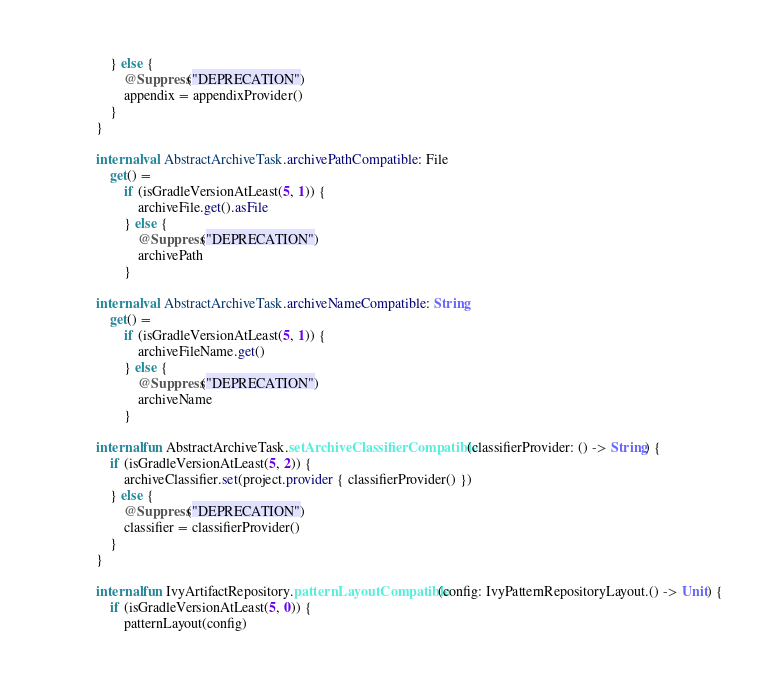<code> <loc_0><loc_0><loc_500><loc_500><_Kotlin_>    } else {
        @Suppress("DEPRECATION")
        appendix = appendixProvider()
    }
}

internal val AbstractArchiveTask.archivePathCompatible: File
    get() =
        if (isGradleVersionAtLeast(5, 1)) {
            archiveFile.get().asFile
        } else {
            @Suppress("DEPRECATION")
            archivePath
        }

internal val AbstractArchiveTask.archiveNameCompatible: String
    get() =
        if (isGradleVersionAtLeast(5, 1)) {
            archiveFileName.get()
        } else {
            @Suppress("DEPRECATION")
            archiveName
        }

internal fun AbstractArchiveTask.setArchiveClassifierCompatible(classifierProvider: () -> String) {
    if (isGradleVersionAtLeast(5, 2)) {
        archiveClassifier.set(project.provider { classifierProvider() })
    } else {
        @Suppress("DEPRECATION")
        classifier = classifierProvider()
    }
}

internal fun IvyArtifactRepository.patternLayoutCompatible(config: IvyPatternRepositoryLayout.() -> Unit) {
    if (isGradleVersionAtLeast(5, 0)) {
        patternLayout(config)</code> 